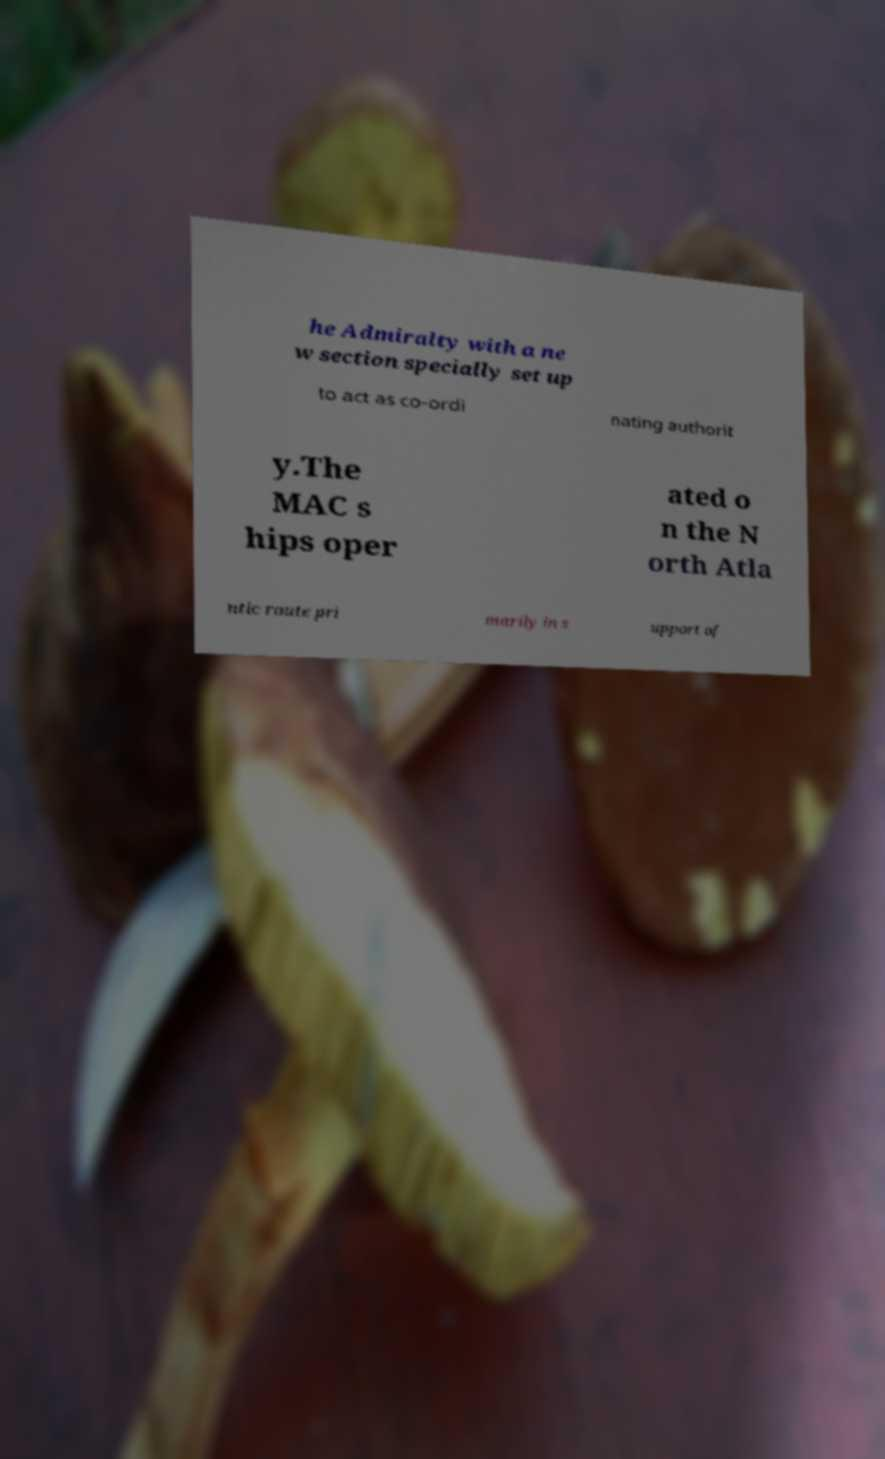Please read and relay the text visible in this image. What does it say? he Admiralty with a ne w section specially set up to act as co-ordi nating authorit y.The MAC s hips oper ated o n the N orth Atla ntic route pri marily in s upport of 